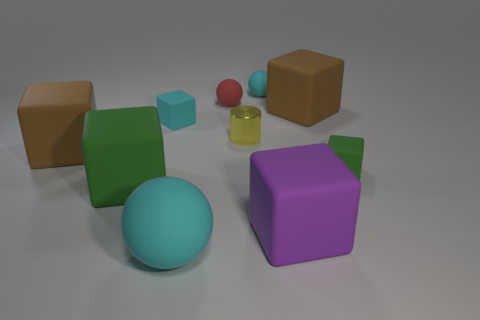The tiny cube that is right of the ball in front of the brown matte object that is behind the yellow metallic object is what color?
Make the answer very short. Green. What is the color of the matte ball that is the same size as the red matte object?
Your response must be concise. Cyan. What shape is the brown object behind the big brown object in front of the large brown cube that is to the right of the metallic cylinder?
Provide a succinct answer. Cube. What number of things are purple blocks or red spheres that are left of the small green matte object?
Your response must be concise. 2. Is the size of the brown block that is behind the metal thing the same as the purple thing?
Provide a short and direct response. Yes. There is a yellow thing that is to the right of the big cyan sphere; what is its material?
Offer a very short reply. Metal. Are there the same number of small matte cubes that are in front of the large green object and big cyan things that are in front of the purple rubber thing?
Your answer should be very brief. No. The other small rubber thing that is the same shape as the tiny green matte thing is what color?
Offer a terse response. Cyan. Is there any other thing of the same color as the large sphere?
Provide a short and direct response. Yes. What number of rubber things are either green things or large things?
Ensure brevity in your answer.  6. 